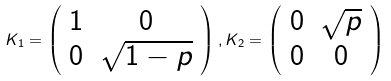<formula> <loc_0><loc_0><loc_500><loc_500>K _ { 1 } = \left ( \begin{array} { c c } 1 & 0 \\ 0 & \sqrt { 1 - p } \end{array} \right ) , K _ { 2 } = \left ( \begin{array} { c c } 0 & \sqrt { p } \\ 0 & 0 \end{array} \right )</formula> 